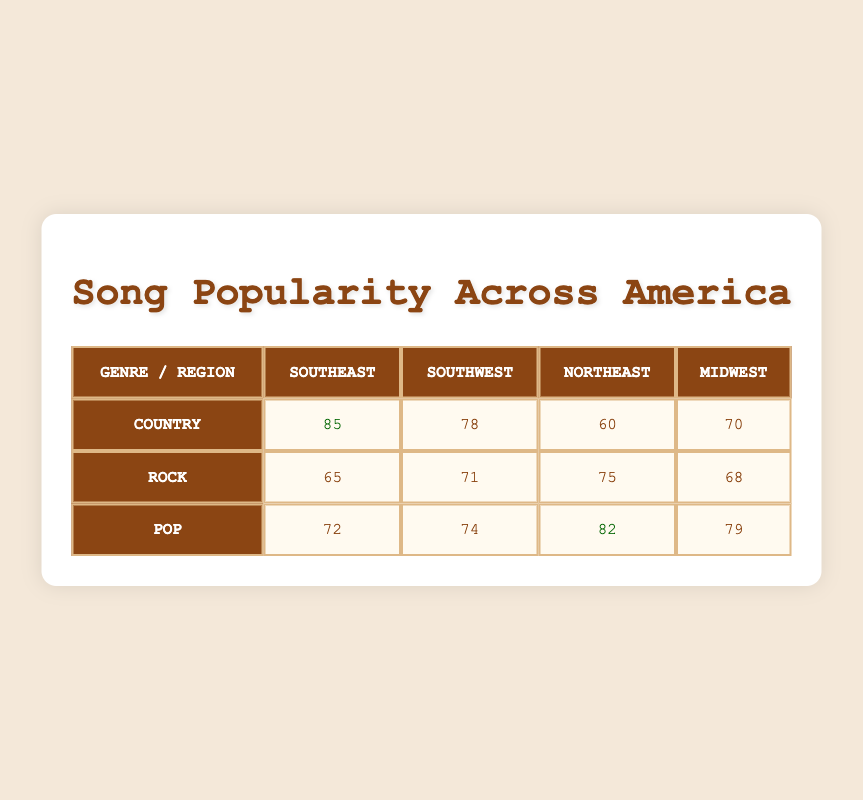What's the popularity score of Country music in the Southeast region? The table shows the popularity score of Country music under the Southeast column, which is 85.
Answer: 85 Which genre has the highest popularity score in the Northeast region? In the Northeast column, the popularity scores are Country (60), Rock (75), and Pop (82). The highest score is from Pop, which is 82.
Answer: Pop What is the average popularity score for Rock music across all regions? The popularity scores for Rock are 65 (Southeast), 71 (Southwest), 75 (Northeast), and 68 (Midwest). Adding these scores gives 65 + 71 + 75 + 68 = 279 and dividing by 4 (the number of regions) gives an average of 279 / 4 = 69.75.
Answer: 69.75 Is the popularity score of Pop music higher in the Midwest or the Southeast? The scores for Pop music are 79 in the Midwest and 72 in the Southeast. Since 79 is greater than 72, Pop music is more popular in the Midwest.
Answer: Yes Which genre has the lowest total popularity score across all regions? Totaling the scores: Country (85 + 78 + 60 + 70 = 293), Rock (65 + 71 + 75 + 68 = 279), and Pop (72 + 74 + 82 + 79 = 307). Rock has the lowest total of 279.
Answer: Rock What is the difference in popularity score between Country music in the Southeast and Northeast? The scores are Country in the Southeast (85) and Northeast (60). The difference is calculated as 85 - 60 = 25.
Answer: 25 Does any genre have a popularity score above 80 in the Southwest region? The scores for the Southwest region are Country (78), Rock (71), and Pop (74). None of these scores exceed 80.
Answer: No What is the total popularity score for Country music across all regions? The scores for Country music are 85 (Southeast), 78 (Southwest), 60 (Northeast), and 70 (Midwest). When added together: 85 + 78 + 60 + 70 = 293.
Answer: 293 Which region has the highest popularity score for Country music? Looking at the Country scores, Southeast is 85, Southwest is 78, Northeast is 60, and Midwest is 70. The highest score is in the Southeast region.
Answer: Southeast 